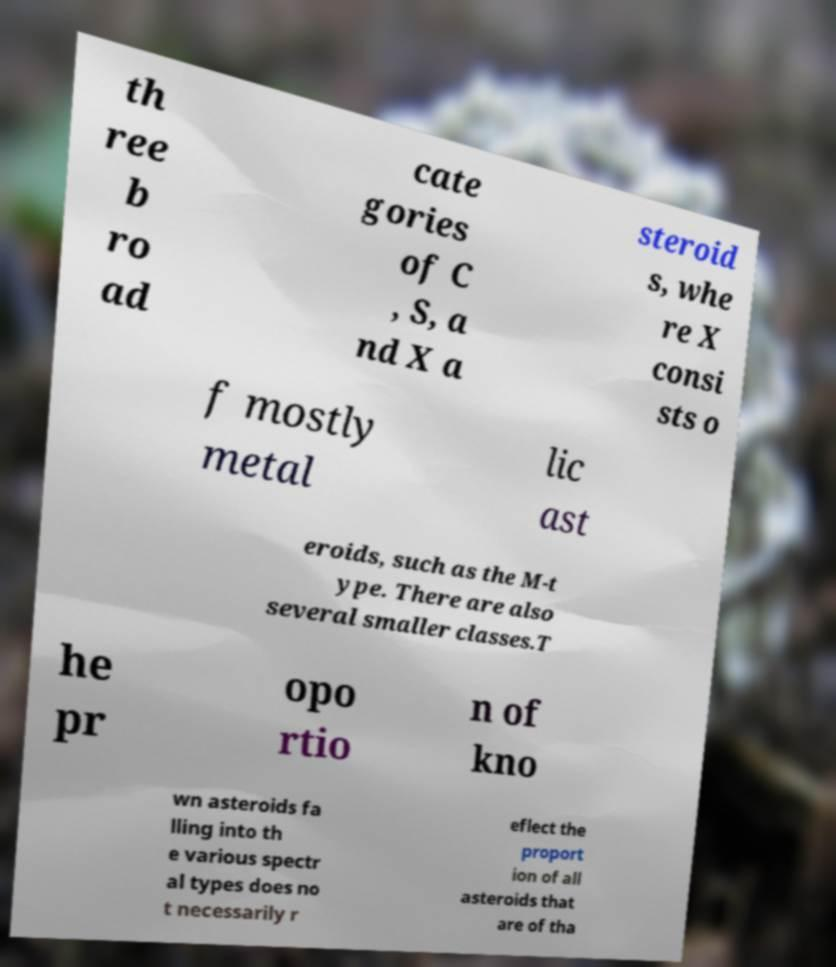Please read and relay the text visible in this image. What does it say? th ree b ro ad cate gories of C , S, a nd X a steroid s, whe re X consi sts o f mostly metal lic ast eroids, such as the M-t ype. There are also several smaller classes.T he pr opo rtio n of kno wn asteroids fa lling into th e various spectr al types does no t necessarily r eflect the proport ion of all asteroids that are of tha 